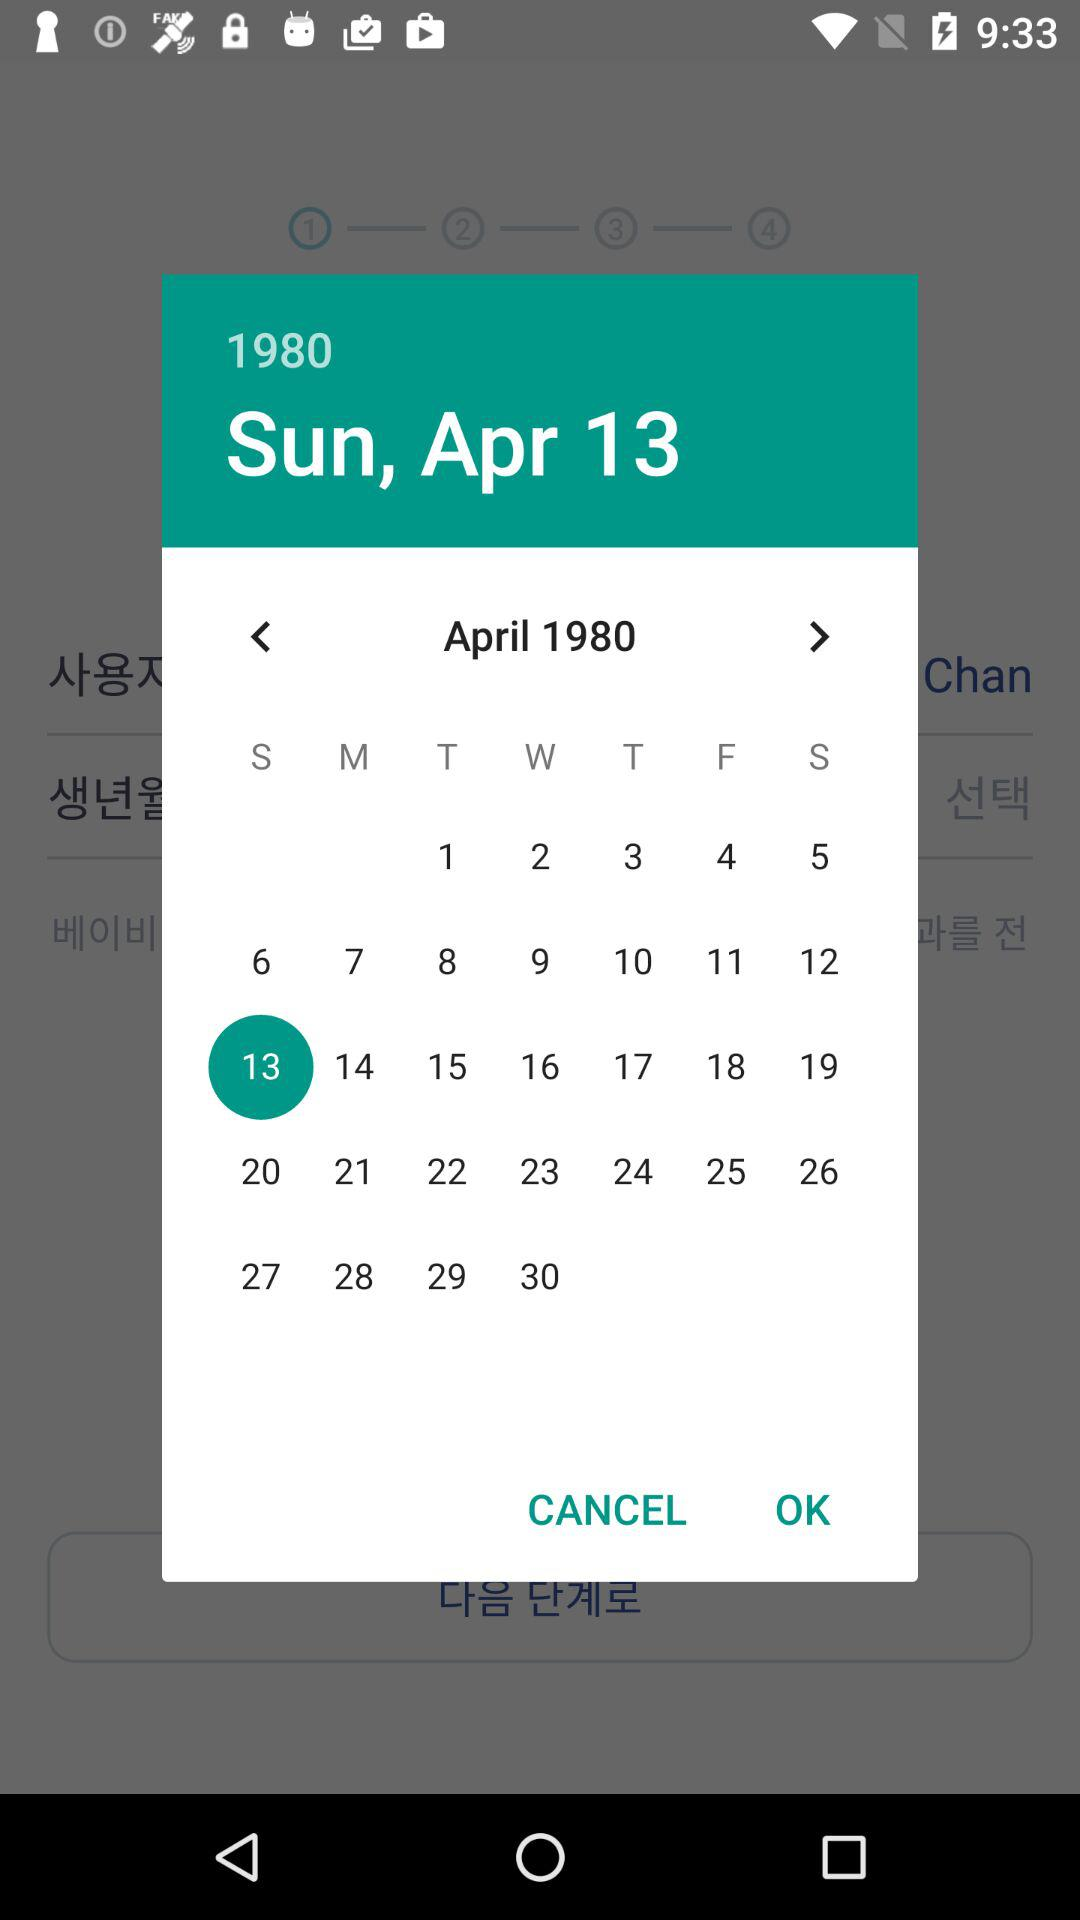What are the month and year shown on the calendar? The shown month and year are April and 1980, respectively. 